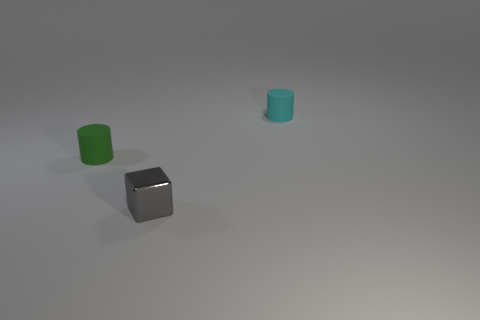Is there a sphere that has the same color as the small metal block?
Offer a very short reply. No. Are the tiny green cylinder and the cylinder to the right of the tiny cube made of the same material?
Make the answer very short. Yes. What number of small things are rubber cylinders or green cylinders?
Ensure brevity in your answer.  2. Is the number of rubber cylinders less than the number of green things?
Offer a terse response. No. There is a matte object left of the small cyan object; is its size the same as the cylinder that is right of the shiny thing?
Your answer should be very brief. Yes. What number of brown objects are either rubber things or tiny things?
Keep it short and to the point. 0. Is the number of tiny gray metallic objects greater than the number of matte spheres?
Ensure brevity in your answer.  Yes. How many objects are either small yellow shiny cubes or tiny green objects that are behind the small metal thing?
Keep it short and to the point. 1. How many other things are the same shape as the cyan matte thing?
Keep it short and to the point. 1. Are there fewer tiny shiny cubes that are in front of the gray metallic object than things in front of the tiny green cylinder?
Provide a succinct answer. Yes. 